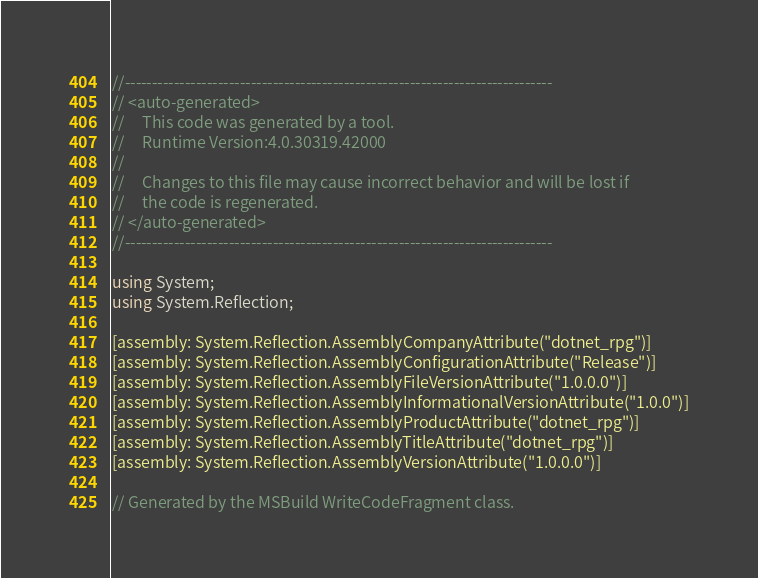Convert code to text. <code><loc_0><loc_0><loc_500><loc_500><_C#_>//------------------------------------------------------------------------------
// <auto-generated>
//     This code was generated by a tool.
//     Runtime Version:4.0.30319.42000
//
//     Changes to this file may cause incorrect behavior and will be lost if
//     the code is regenerated.
// </auto-generated>
//------------------------------------------------------------------------------

using System;
using System.Reflection;

[assembly: System.Reflection.AssemblyCompanyAttribute("dotnet_rpg")]
[assembly: System.Reflection.AssemblyConfigurationAttribute("Release")]
[assembly: System.Reflection.AssemblyFileVersionAttribute("1.0.0.0")]
[assembly: System.Reflection.AssemblyInformationalVersionAttribute("1.0.0")]
[assembly: System.Reflection.AssemblyProductAttribute("dotnet_rpg")]
[assembly: System.Reflection.AssemblyTitleAttribute("dotnet_rpg")]
[assembly: System.Reflection.AssemblyVersionAttribute("1.0.0.0")]

// Generated by the MSBuild WriteCodeFragment class.

</code> 